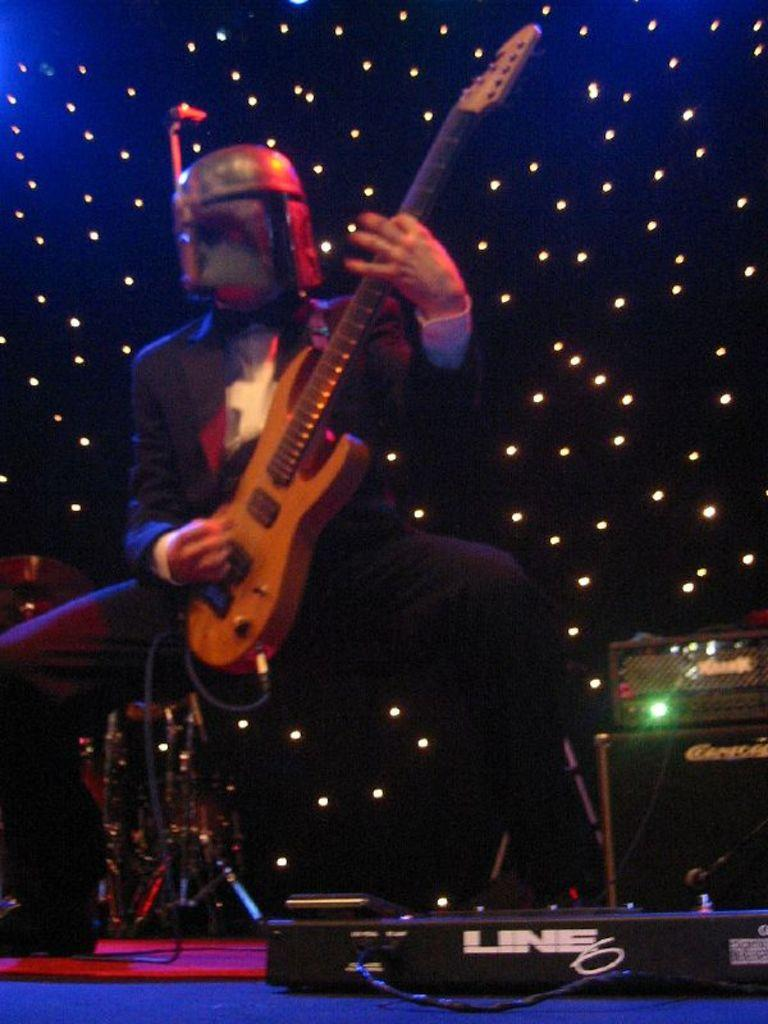Who is the person in the image? There is a man in the image. What is the man wearing on his head? The man is wearing a helmet. What is the man holding in the image? The man is holding a guitar. What is the man doing with the guitar? The man is playing the guitar. What can be seen in the background of the image? There are lights in the background of the image. What is located in the front of the image? There is a musical instrument in the front of the image. What type of copper material is the man using to express his anger in the image? There is no copper material or expression of anger present in the image. The man is playing a guitar, and there is no indication of anger or copper in the image. 